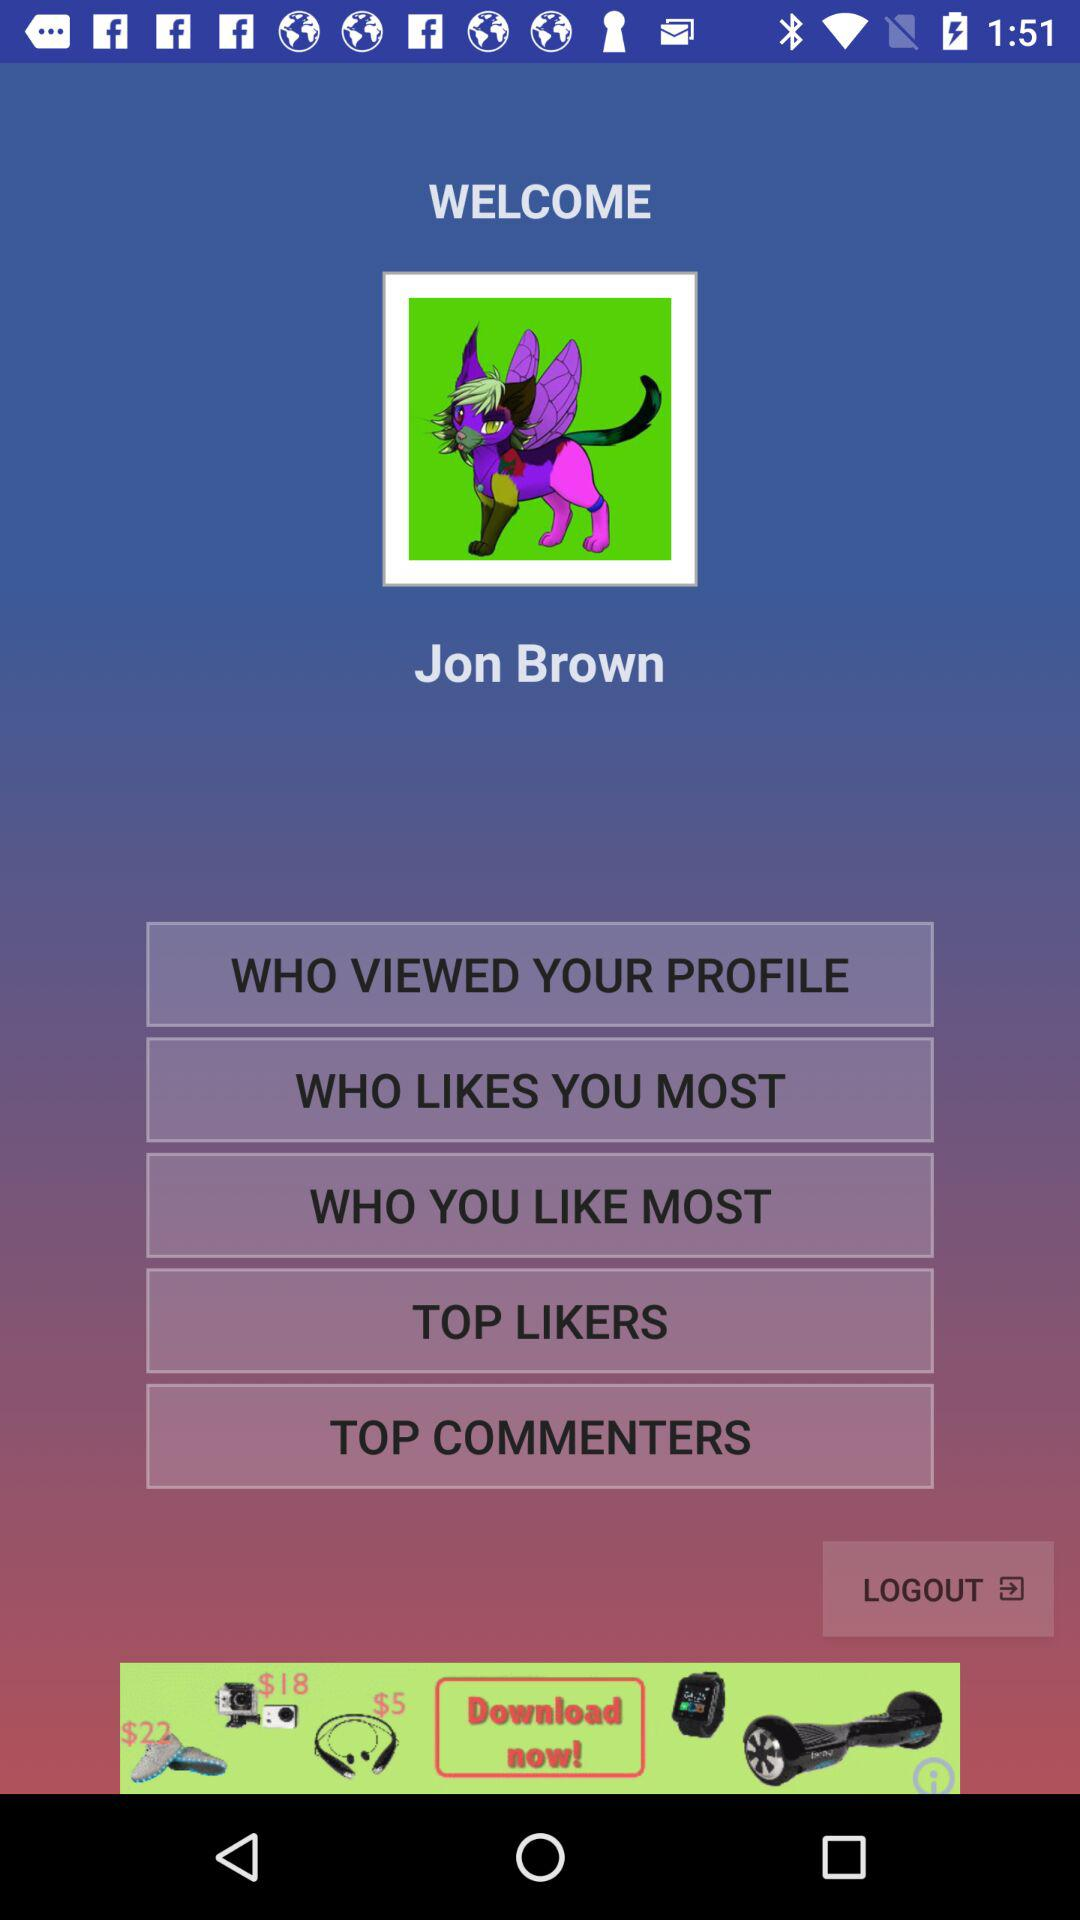What is the user name? The user name is Jon Brown. 